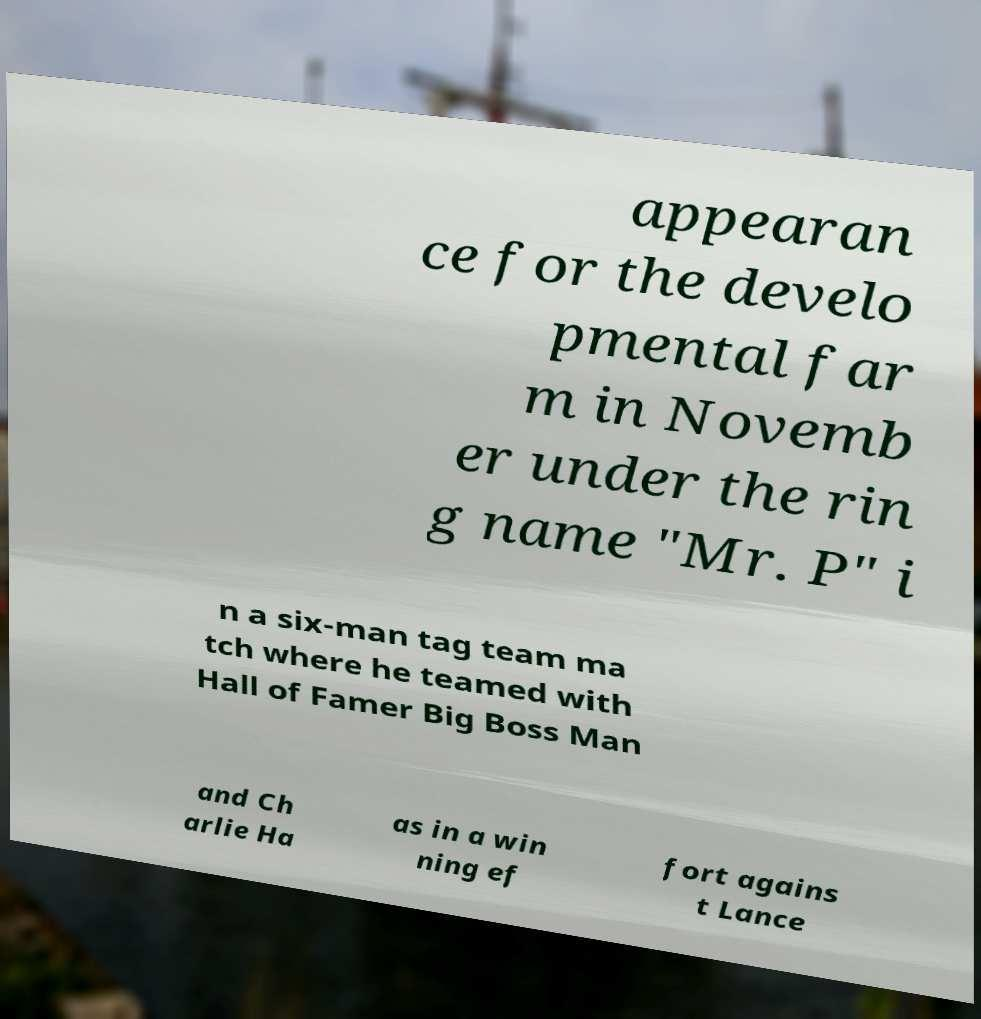Could you assist in decoding the text presented in this image and type it out clearly? appearan ce for the develo pmental far m in Novemb er under the rin g name "Mr. P" i n a six-man tag team ma tch where he teamed with Hall of Famer Big Boss Man and Ch arlie Ha as in a win ning ef fort agains t Lance 